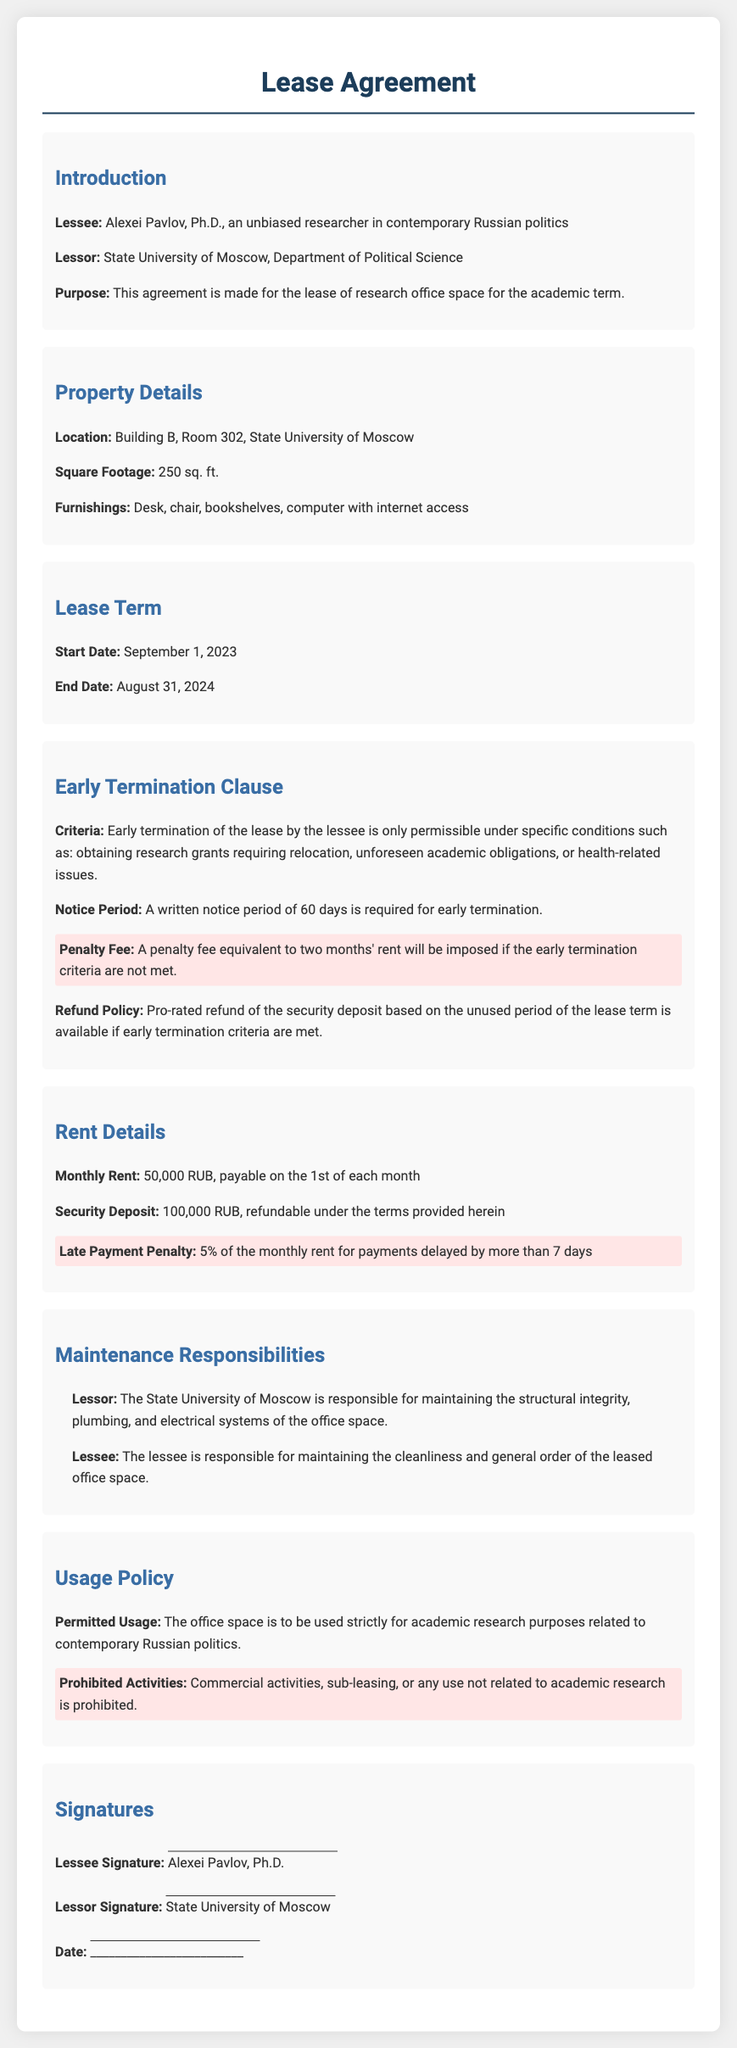What is the lessee's name? The lessee is Alexei Pavlov, Ph.D.
Answer: Alexei Pavlov, Ph.D What is the location of the leased property? The location of the property is specified in the document.
Answer: Building B, Room 302, State University of Moscow What is the monthly rent? The document specifies the monthly rent amount.
Answer: 50,000 RUB What is the penalty fee for early termination if criteria are not met? The document states the penalty for not meeting early termination criteria.
Answer: A penalty fee equivalent to two months' rent What is the notice period required for early termination? The notice period is mentioned in the terms of the lease.
Answer: 60 days What is the purpose of the lease? The purpose of the lease is provided in the introduction section.
Answer: Lease of research office space for the academic term What responsibilities does the lessee have regarding maintenance? The lessee's responsibilities are outlined in the maintenance section.
Answer: Maintaining cleanliness and general order What is the refundable amount of the security deposit? The refundable amount is mentioned within the rent details.
Answer: 100,000 RUB What activities are prohibited in the leased office space? The document lists prohibited activities under the usage policy.
Answer: Commercial activities, sub-leasing, or any use not related to academic research 